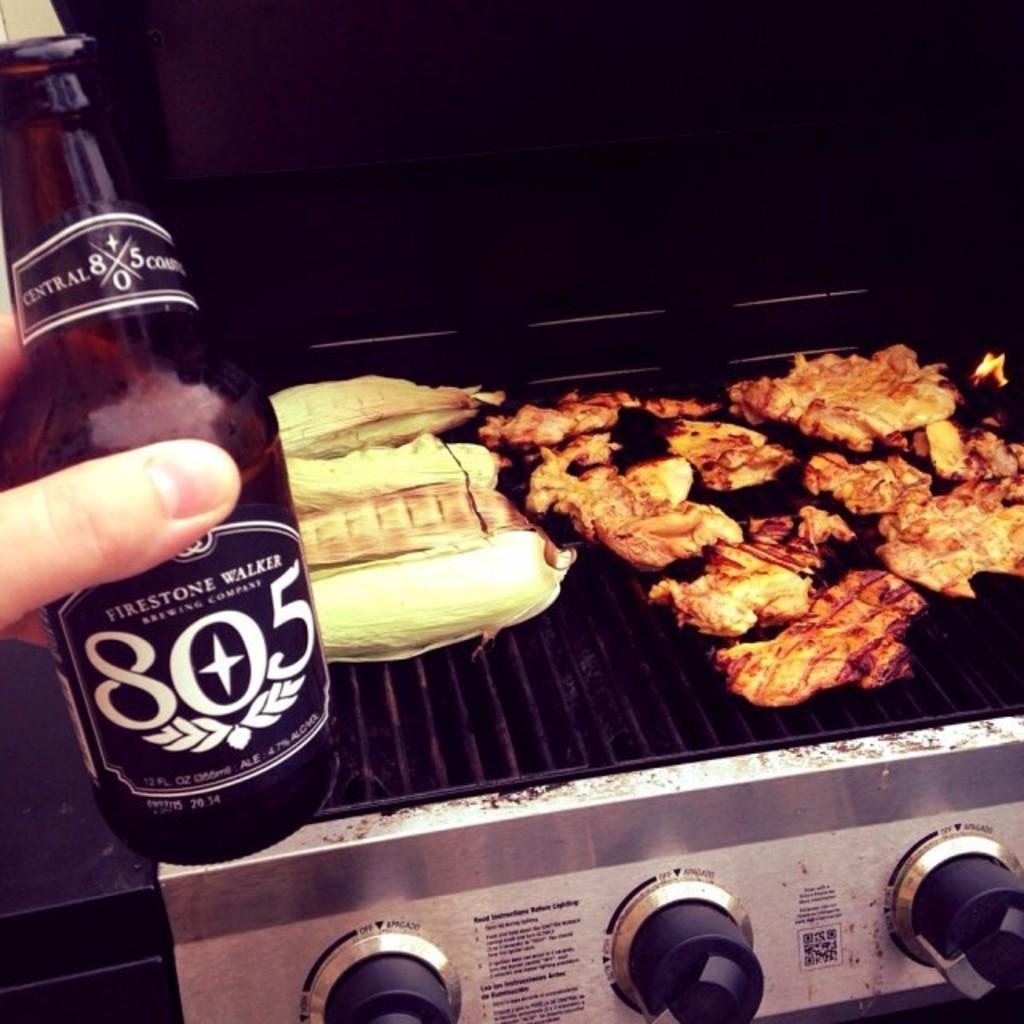<image>
Provide a brief description of the given image. A hand holds up a bottle of 805 in front of a grill. 